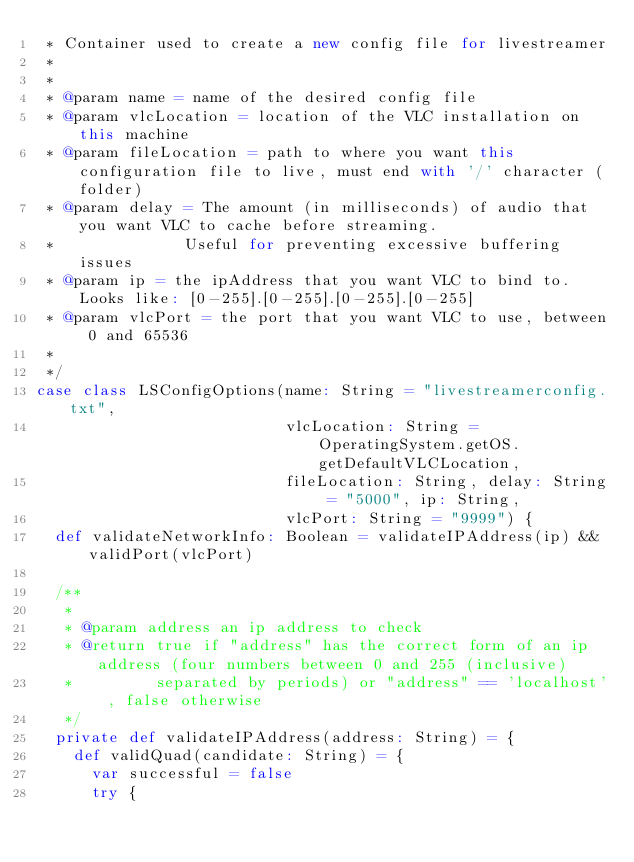Convert code to text. <code><loc_0><loc_0><loc_500><loc_500><_Scala_> * Container used to create a new config file for livestreamer
 *
 *
 * @param name = name of the desired config file
 * @param vlcLocation = location of the VLC installation on this machine
 * @param fileLocation = path to where you want this configuration file to live, must end with '/' character (folder)
 * @param delay = The amount (in milliseconds) of audio that you want VLC to cache before streaming.
 *              Useful for preventing excessive buffering issues
 * @param ip = the ipAddress that you want VLC to bind to. Looks like: [0-255].[0-255].[0-255].[0-255]
 * @param vlcPort = the port that you want VLC to use, between 0 and 65536
 *
 */
case class LSConfigOptions(name: String = "livestreamerconfig.txt",
                           vlcLocation: String = OperatingSystem.getOS.getDefaultVLCLocation,
                           fileLocation: String, delay: String = "5000", ip: String,
                           vlcPort: String = "9999") {
  def validateNetworkInfo: Boolean = validateIPAddress(ip) && validPort(vlcPort)

  /**
   *
   * @param address an ip address to check
   * @return true if "address" has the correct form of an ip address (four numbers between 0 and 255 (inclusive) 
   *         separated by periods) or "address" == 'localhost' , false otherwise
   */
  private def validateIPAddress(address: String) = {
    def validQuad(candidate: String) = {
      var successful = false
      try {</code> 